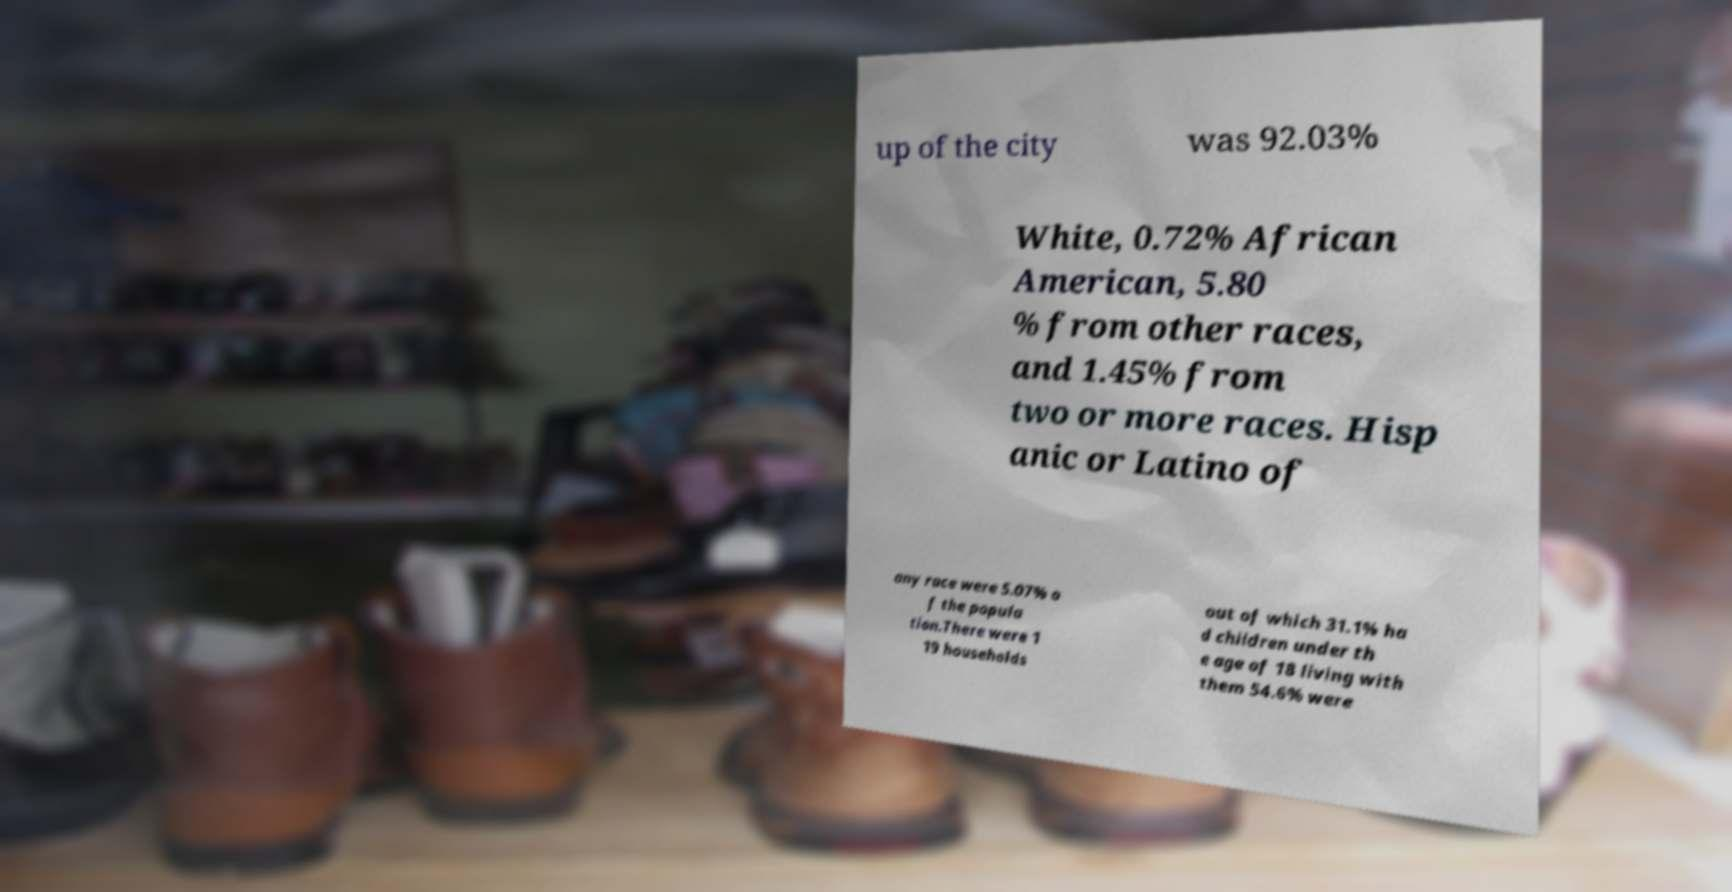There's text embedded in this image that I need extracted. Can you transcribe it verbatim? up of the city was 92.03% White, 0.72% African American, 5.80 % from other races, and 1.45% from two or more races. Hisp anic or Latino of any race were 5.07% o f the popula tion.There were 1 19 households out of which 31.1% ha d children under th e age of 18 living with them 54.6% were 